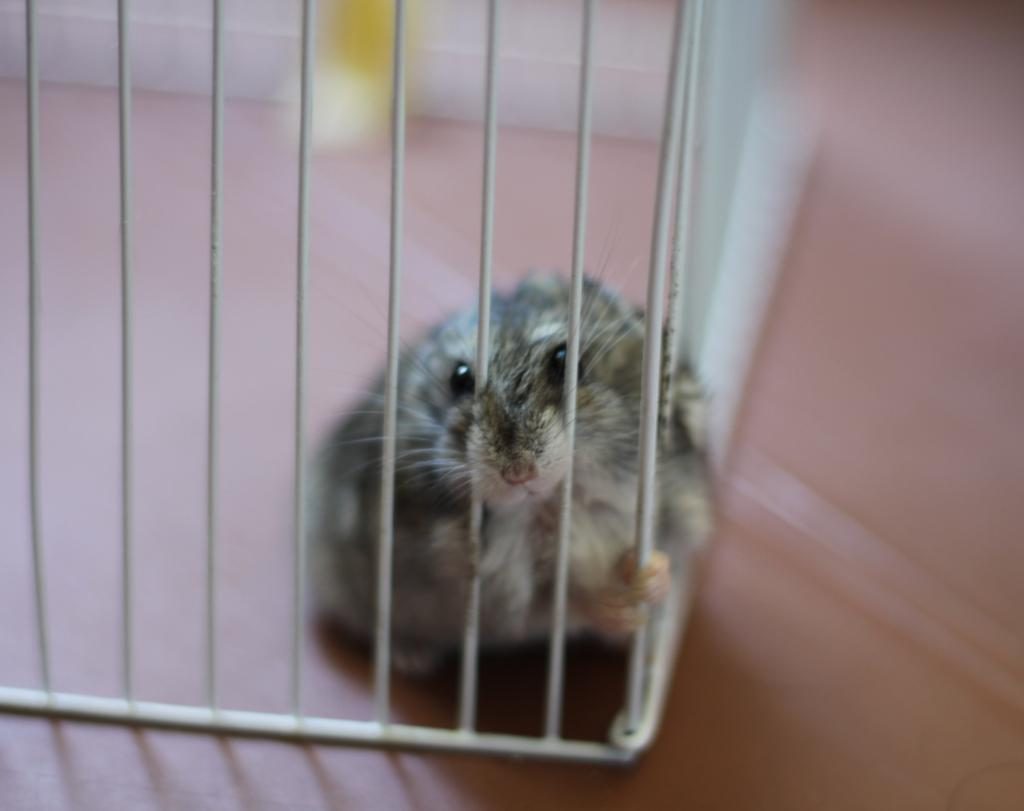What type of animal is in the image? There is a rat in the image. What is the color of the small grill in the image? The small grill in the image is white in color. What is the background of the image? There is a wall in the image. What is the color of the object in the image? The object in the image is yellow in color. How long does it take for the rat's grandmother to make wax candles in the image? There is no mention of a grandmother or wax candles in the image, so it is not possible to answer this question. 